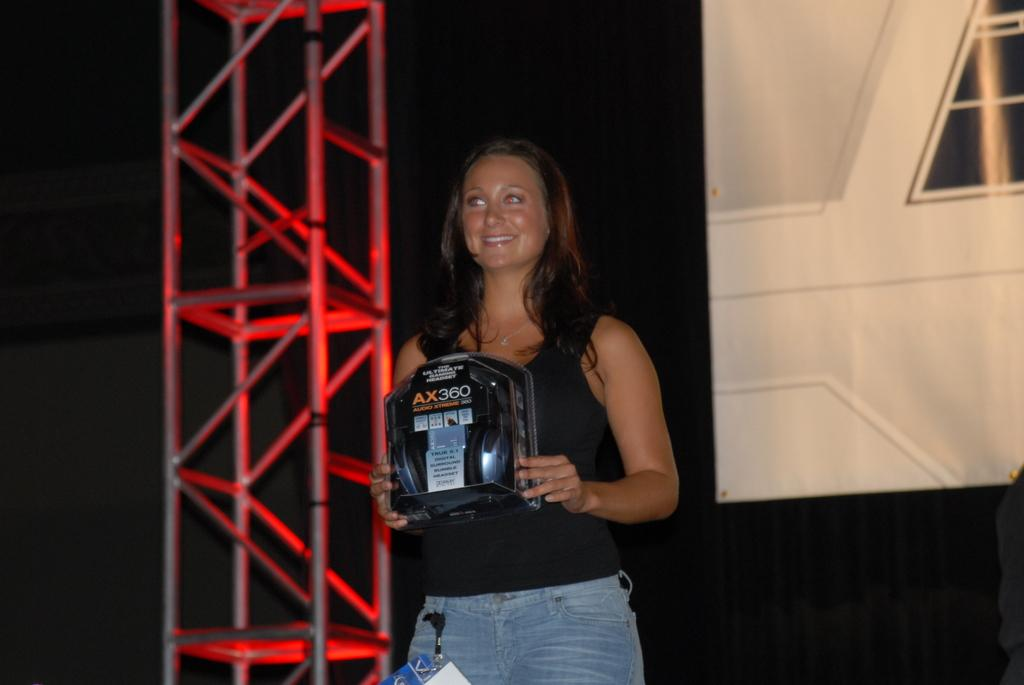Who is the main subject in the image? There is a woman in the image. What is the woman wearing? The woman is wearing a black t-shirt. What is the woman holding in the image? The woman is holding an object. What can be seen in the background of the image? The background of the image is black. What type of sand is visible in the woman's hair in the image? There is no sand visible in the image, and the woman's hair is not mentioned in the provided facts. 